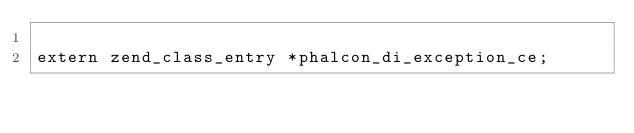Convert code to text. <code><loc_0><loc_0><loc_500><loc_500><_C_>
extern zend_class_entry *phalcon_di_exception_ce;
</code> 